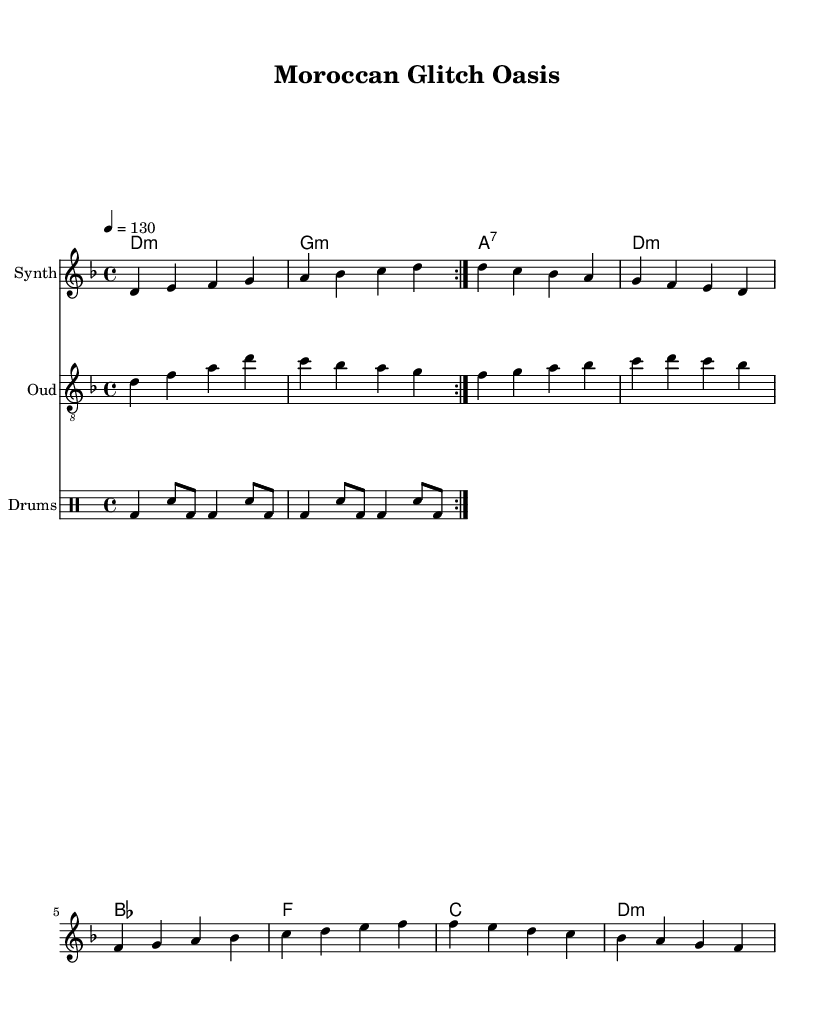What is the key signature of this music? The key signature is indicated by the presence of a flat on the fourth line of the staff, which represents the note D. Thus, it indicates D minor.
Answer: D minor What is the time signature of this composition? The time signature is found at the beginning of the sheet music, displayed as 4 over 4, indicating a common time.
Answer: 4/4 What is the tempo marking in beats per minute? The tempo marking is notated in the global section, showing that the piece should be played at 130 beats per minute.
Answer: 130 How many measures are in the synth melody section? Counting the measures in the synth melody, we find a total of eight measures present.
Answer: 8 Which instrument has the clef "treble_8"? The clef "treble_8" is specified under the Oud part, indicating that the Oud is written an octave higher than it sounds.
Answer: Oud What chord follows the D minor chord in the chord progression? Examining the chord progression notated below the staff, we see that the chord following D minor is G minor.
Answer: G minor What two musical styles are fused in this composition? The title and sections indicate that elements of Moroccan trance and glitch music are combined, reflecting its experimental electronic roots.
Answer: Moroccan trance and glitch 